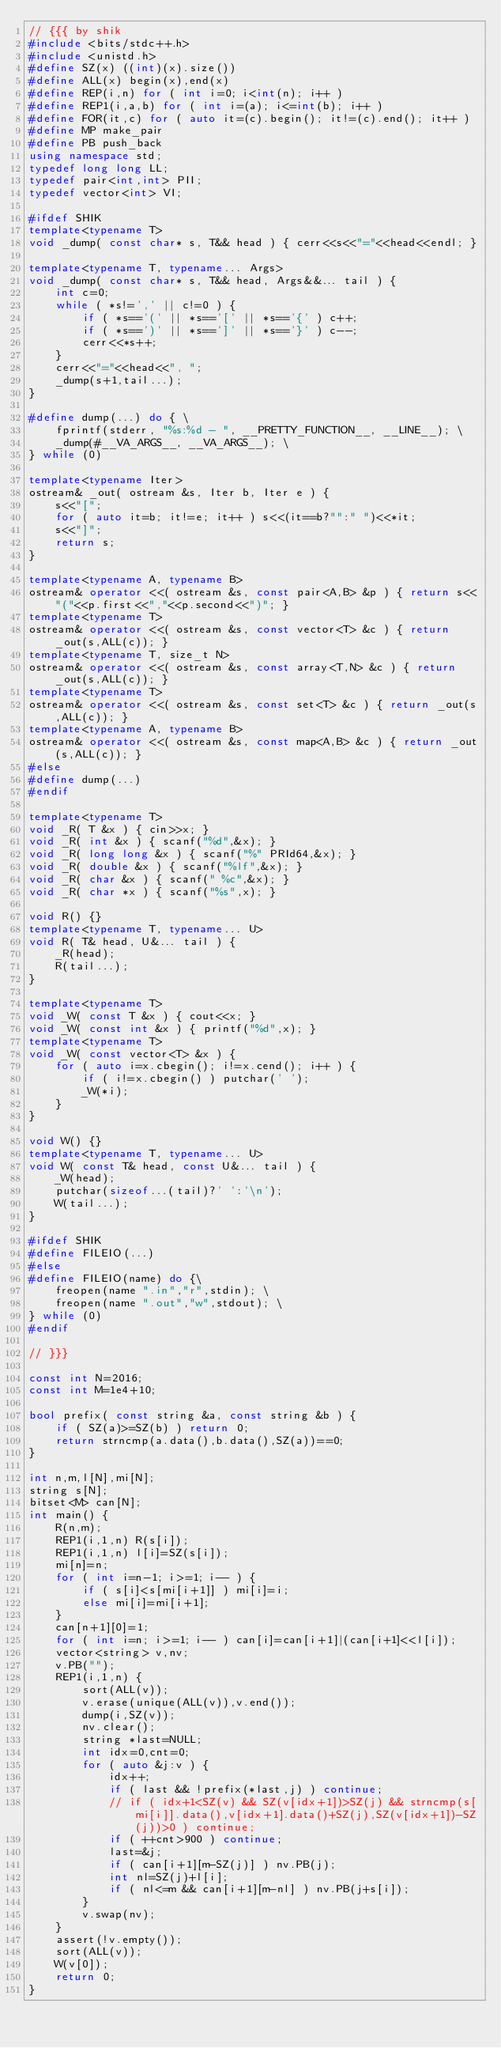Convert code to text. <code><loc_0><loc_0><loc_500><loc_500><_C++_>// {{{ by shik
#include <bits/stdc++.h>
#include <unistd.h>
#define SZ(x) ((int)(x).size())
#define ALL(x) begin(x),end(x)
#define REP(i,n) for ( int i=0; i<int(n); i++ )
#define REP1(i,a,b) for ( int i=(a); i<=int(b); i++ )
#define FOR(it,c) for ( auto it=(c).begin(); it!=(c).end(); it++ )
#define MP make_pair
#define PB push_back
using namespace std;
typedef long long LL;
typedef pair<int,int> PII;
typedef vector<int> VI;

#ifdef SHIK
template<typename T>
void _dump( const char* s, T&& head ) { cerr<<s<<"="<<head<<endl; }

template<typename T, typename... Args>
void _dump( const char* s, T&& head, Args&&... tail ) {
    int c=0;
    while ( *s!=',' || c!=0 ) {
        if ( *s=='(' || *s=='[' || *s=='{' ) c++;
        if ( *s==')' || *s==']' || *s=='}' ) c--;
        cerr<<*s++;
    }
    cerr<<"="<<head<<", ";
    _dump(s+1,tail...);
}

#define dump(...) do { \
    fprintf(stderr, "%s:%d - ", __PRETTY_FUNCTION__, __LINE__); \
    _dump(#__VA_ARGS__, __VA_ARGS__); \
} while (0)

template<typename Iter>
ostream& _out( ostream &s, Iter b, Iter e ) {
    s<<"[";
    for ( auto it=b; it!=e; it++ ) s<<(it==b?"":" ")<<*it;
    s<<"]";
    return s;
}

template<typename A, typename B>
ostream& operator <<( ostream &s, const pair<A,B> &p ) { return s<<"("<<p.first<<","<<p.second<<")"; }
template<typename T>
ostream& operator <<( ostream &s, const vector<T> &c ) { return _out(s,ALL(c)); }
template<typename T, size_t N>
ostream& operator <<( ostream &s, const array<T,N> &c ) { return _out(s,ALL(c)); }
template<typename T>
ostream& operator <<( ostream &s, const set<T> &c ) { return _out(s,ALL(c)); }
template<typename A, typename B>
ostream& operator <<( ostream &s, const map<A,B> &c ) { return _out(s,ALL(c)); }
#else
#define dump(...)
#endif

template<typename T>
void _R( T &x ) { cin>>x; }
void _R( int &x ) { scanf("%d",&x); }
void _R( long long &x ) { scanf("%" PRId64,&x); }
void _R( double &x ) { scanf("%lf",&x); }
void _R( char &x ) { scanf(" %c",&x); }
void _R( char *x ) { scanf("%s",x); }

void R() {}
template<typename T, typename... U>
void R( T& head, U&... tail ) {
    _R(head);
    R(tail...);
}

template<typename T>
void _W( const T &x ) { cout<<x; }
void _W( const int &x ) { printf("%d",x); }
template<typename T>
void _W( const vector<T> &x ) {
    for ( auto i=x.cbegin(); i!=x.cend(); i++ ) {
        if ( i!=x.cbegin() ) putchar(' ');
        _W(*i);
    }
}

void W() {}
template<typename T, typename... U>
void W( const T& head, const U&... tail ) {
    _W(head);
    putchar(sizeof...(tail)?' ':'\n');
    W(tail...);
}

#ifdef SHIK
#define FILEIO(...)
#else
#define FILEIO(name) do {\
    freopen(name ".in","r",stdin); \
    freopen(name ".out","w",stdout); \
} while (0)
#endif

// }}}

const int N=2016;
const int M=1e4+10;

bool prefix( const string &a, const string &b ) {
    if ( SZ(a)>=SZ(b) ) return 0;
    return strncmp(a.data(),b.data(),SZ(a))==0;
}

int n,m,l[N],mi[N];
string s[N];
bitset<M> can[N];
int main() {
    R(n,m);
    REP1(i,1,n) R(s[i]);
    REP1(i,1,n) l[i]=SZ(s[i]);
    mi[n]=n;
    for ( int i=n-1; i>=1; i-- ) {
        if ( s[i]<s[mi[i+1]] ) mi[i]=i;
        else mi[i]=mi[i+1];
    }
    can[n+1][0]=1;
    for ( int i=n; i>=1; i-- ) can[i]=can[i+1]|(can[i+1]<<l[i]);
    vector<string> v,nv;
    v.PB("");
    REP1(i,1,n) {
        sort(ALL(v));
        v.erase(unique(ALL(v)),v.end());
        dump(i,SZ(v));
        nv.clear();
        string *last=NULL;
        int idx=0,cnt=0;
        for ( auto &j:v ) {
            idx++;
            if ( last && !prefix(*last,j) ) continue;
            // if ( idx+1<SZ(v) && SZ(v[idx+1])>SZ(j) && strncmp(s[mi[i]].data(),v[idx+1].data()+SZ(j),SZ(v[idx+1])-SZ(j))>0 ) continue;
            if ( ++cnt>900 ) continue;
            last=&j;
            if ( can[i+1][m-SZ(j)] ) nv.PB(j);
            int nl=SZ(j)+l[i];
            if ( nl<=m && can[i+1][m-nl] ) nv.PB(j+s[i]);
        }
        v.swap(nv);
    }
    assert(!v.empty());
    sort(ALL(v));
    W(v[0]);
    return 0;
}
</code> 